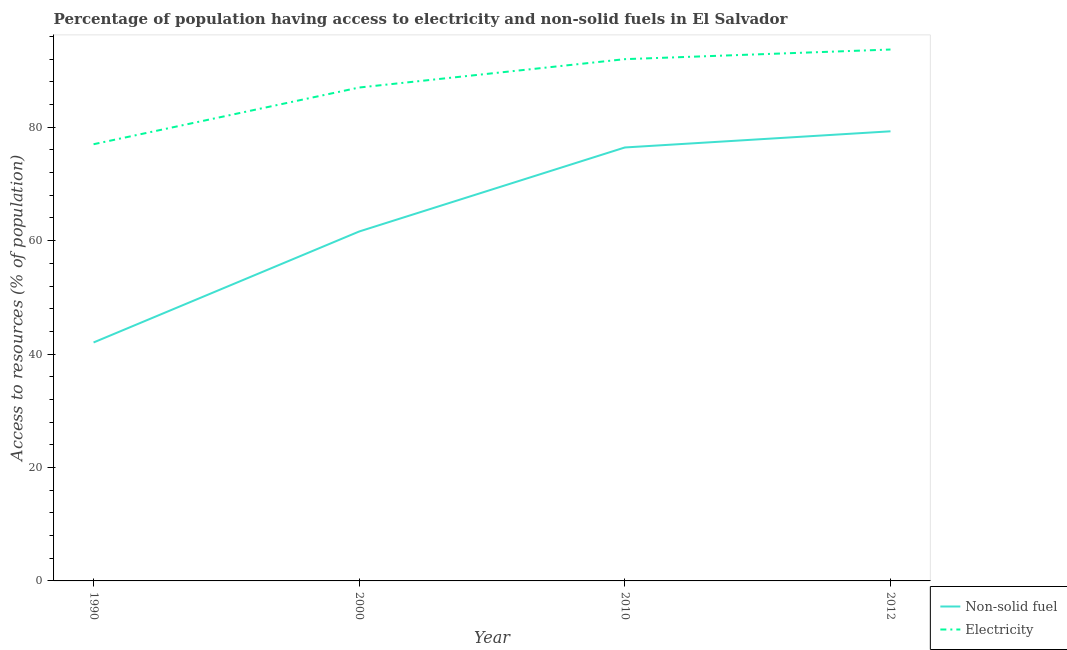Does the line corresponding to percentage of population having access to non-solid fuel intersect with the line corresponding to percentage of population having access to electricity?
Provide a succinct answer. No. What is the percentage of population having access to electricity in 2010?
Give a very brief answer. 92. Across all years, what is the maximum percentage of population having access to electricity?
Ensure brevity in your answer.  93.7. What is the total percentage of population having access to electricity in the graph?
Offer a very short reply. 349.7. What is the difference between the percentage of population having access to electricity in 1990 and that in 2010?
Give a very brief answer. -15. What is the difference between the percentage of population having access to non-solid fuel in 2010 and the percentage of population having access to electricity in 2000?
Make the answer very short. -10.57. What is the average percentage of population having access to electricity per year?
Your response must be concise. 87.42. In the year 2000, what is the difference between the percentage of population having access to electricity and percentage of population having access to non-solid fuel?
Ensure brevity in your answer.  25.39. In how many years, is the percentage of population having access to non-solid fuel greater than 68 %?
Provide a succinct answer. 2. What is the ratio of the percentage of population having access to electricity in 1990 to that in 2000?
Ensure brevity in your answer.  0.89. Is the percentage of population having access to non-solid fuel in 1990 less than that in 2010?
Provide a short and direct response. Yes. Is the difference between the percentage of population having access to non-solid fuel in 1990 and 2012 greater than the difference between the percentage of population having access to electricity in 1990 and 2012?
Give a very brief answer. No. What is the difference between the highest and the second highest percentage of population having access to electricity?
Offer a terse response. 1.7. What is the difference between the highest and the lowest percentage of population having access to non-solid fuel?
Provide a succinct answer. 37.23. Is the sum of the percentage of population having access to non-solid fuel in 2000 and 2012 greater than the maximum percentage of population having access to electricity across all years?
Offer a terse response. Yes. Is the percentage of population having access to non-solid fuel strictly greater than the percentage of population having access to electricity over the years?
Keep it short and to the point. No. Is the percentage of population having access to non-solid fuel strictly less than the percentage of population having access to electricity over the years?
Make the answer very short. Yes. How many years are there in the graph?
Offer a very short reply. 4. What is the difference between two consecutive major ticks on the Y-axis?
Offer a very short reply. 20. Are the values on the major ticks of Y-axis written in scientific E-notation?
Ensure brevity in your answer.  No. What is the title of the graph?
Your answer should be compact. Percentage of population having access to electricity and non-solid fuels in El Salvador. What is the label or title of the Y-axis?
Ensure brevity in your answer.  Access to resources (% of population). What is the Access to resources (% of population) of Non-solid fuel in 1990?
Your answer should be very brief. 42.05. What is the Access to resources (% of population) in Electricity in 1990?
Make the answer very short. 77. What is the Access to resources (% of population) in Non-solid fuel in 2000?
Keep it short and to the point. 61.61. What is the Access to resources (% of population) in Electricity in 2000?
Offer a terse response. 87. What is the Access to resources (% of population) of Non-solid fuel in 2010?
Your answer should be compact. 76.43. What is the Access to resources (% of population) of Electricity in 2010?
Provide a succinct answer. 92. What is the Access to resources (% of population) in Non-solid fuel in 2012?
Make the answer very short. 79.28. What is the Access to resources (% of population) in Electricity in 2012?
Your response must be concise. 93.7. Across all years, what is the maximum Access to resources (% of population) in Non-solid fuel?
Your response must be concise. 79.28. Across all years, what is the maximum Access to resources (% of population) of Electricity?
Offer a very short reply. 93.7. Across all years, what is the minimum Access to resources (% of population) in Non-solid fuel?
Offer a very short reply. 42.05. Across all years, what is the minimum Access to resources (% of population) in Electricity?
Your answer should be compact. 77. What is the total Access to resources (% of population) in Non-solid fuel in the graph?
Provide a short and direct response. 259.37. What is the total Access to resources (% of population) of Electricity in the graph?
Offer a terse response. 349.7. What is the difference between the Access to resources (% of population) of Non-solid fuel in 1990 and that in 2000?
Your response must be concise. -19.57. What is the difference between the Access to resources (% of population) in Non-solid fuel in 1990 and that in 2010?
Keep it short and to the point. -34.38. What is the difference between the Access to resources (% of population) in Electricity in 1990 and that in 2010?
Offer a very short reply. -15. What is the difference between the Access to resources (% of population) in Non-solid fuel in 1990 and that in 2012?
Provide a short and direct response. -37.23. What is the difference between the Access to resources (% of population) of Electricity in 1990 and that in 2012?
Offer a very short reply. -16.7. What is the difference between the Access to resources (% of population) of Non-solid fuel in 2000 and that in 2010?
Your response must be concise. -14.81. What is the difference between the Access to resources (% of population) in Electricity in 2000 and that in 2010?
Your answer should be very brief. -5. What is the difference between the Access to resources (% of population) of Non-solid fuel in 2000 and that in 2012?
Provide a short and direct response. -17.66. What is the difference between the Access to resources (% of population) in Non-solid fuel in 2010 and that in 2012?
Ensure brevity in your answer.  -2.85. What is the difference between the Access to resources (% of population) of Electricity in 2010 and that in 2012?
Provide a short and direct response. -1.7. What is the difference between the Access to resources (% of population) in Non-solid fuel in 1990 and the Access to resources (% of population) in Electricity in 2000?
Your answer should be compact. -44.95. What is the difference between the Access to resources (% of population) in Non-solid fuel in 1990 and the Access to resources (% of population) in Electricity in 2010?
Give a very brief answer. -49.95. What is the difference between the Access to resources (% of population) of Non-solid fuel in 1990 and the Access to resources (% of population) of Electricity in 2012?
Your response must be concise. -51.65. What is the difference between the Access to resources (% of population) in Non-solid fuel in 2000 and the Access to resources (% of population) in Electricity in 2010?
Provide a succinct answer. -30.39. What is the difference between the Access to resources (% of population) of Non-solid fuel in 2000 and the Access to resources (% of population) of Electricity in 2012?
Your answer should be compact. -32.09. What is the difference between the Access to resources (% of population) of Non-solid fuel in 2010 and the Access to resources (% of population) of Electricity in 2012?
Provide a short and direct response. -17.27. What is the average Access to resources (% of population) in Non-solid fuel per year?
Give a very brief answer. 64.84. What is the average Access to resources (% of population) of Electricity per year?
Your answer should be very brief. 87.42. In the year 1990, what is the difference between the Access to resources (% of population) of Non-solid fuel and Access to resources (% of population) of Electricity?
Offer a terse response. -34.95. In the year 2000, what is the difference between the Access to resources (% of population) in Non-solid fuel and Access to resources (% of population) in Electricity?
Your answer should be very brief. -25.39. In the year 2010, what is the difference between the Access to resources (% of population) in Non-solid fuel and Access to resources (% of population) in Electricity?
Keep it short and to the point. -15.57. In the year 2012, what is the difference between the Access to resources (% of population) of Non-solid fuel and Access to resources (% of population) of Electricity?
Ensure brevity in your answer.  -14.42. What is the ratio of the Access to resources (% of population) in Non-solid fuel in 1990 to that in 2000?
Make the answer very short. 0.68. What is the ratio of the Access to resources (% of population) in Electricity in 1990 to that in 2000?
Your response must be concise. 0.89. What is the ratio of the Access to resources (% of population) in Non-solid fuel in 1990 to that in 2010?
Provide a short and direct response. 0.55. What is the ratio of the Access to resources (% of population) of Electricity in 1990 to that in 2010?
Give a very brief answer. 0.84. What is the ratio of the Access to resources (% of population) in Non-solid fuel in 1990 to that in 2012?
Offer a very short reply. 0.53. What is the ratio of the Access to resources (% of population) in Electricity in 1990 to that in 2012?
Keep it short and to the point. 0.82. What is the ratio of the Access to resources (% of population) of Non-solid fuel in 2000 to that in 2010?
Your answer should be compact. 0.81. What is the ratio of the Access to resources (% of population) of Electricity in 2000 to that in 2010?
Your response must be concise. 0.95. What is the ratio of the Access to resources (% of population) in Non-solid fuel in 2000 to that in 2012?
Your answer should be compact. 0.78. What is the ratio of the Access to resources (% of population) of Electricity in 2000 to that in 2012?
Your response must be concise. 0.93. What is the ratio of the Access to resources (% of population) of Non-solid fuel in 2010 to that in 2012?
Your response must be concise. 0.96. What is the ratio of the Access to resources (% of population) in Electricity in 2010 to that in 2012?
Keep it short and to the point. 0.98. What is the difference between the highest and the second highest Access to resources (% of population) of Non-solid fuel?
Offer a very short reply. 2.85. What is the difference between the highest and the lowest Access to resources (% of population) of Non-solid fuel?
Provide a succinct answer. 37.23. 